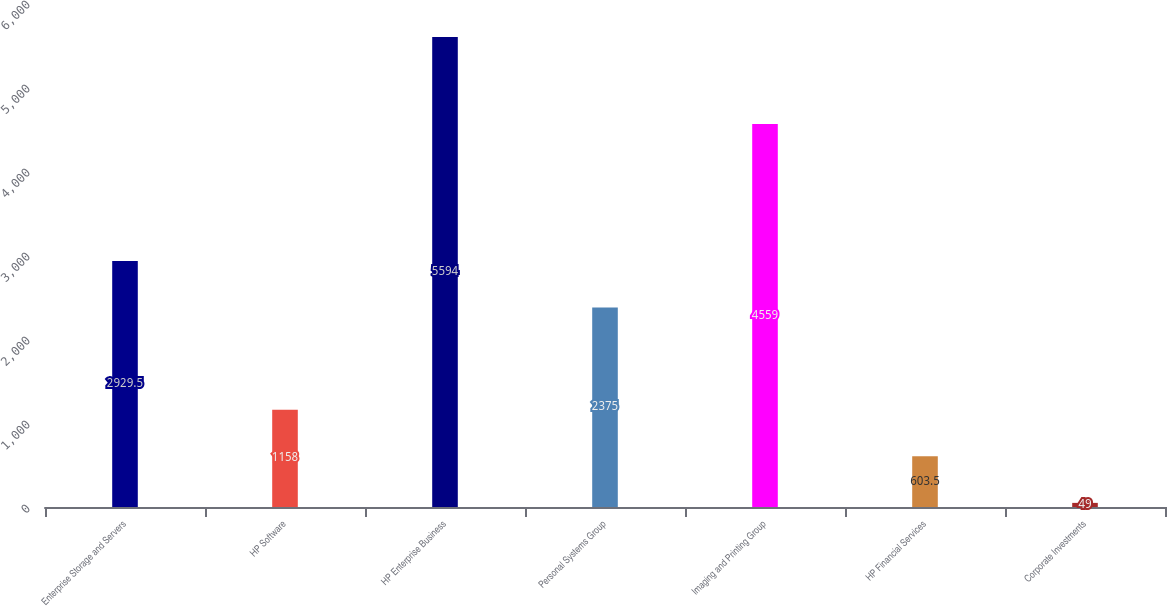Convert chart. <chart><loc_0><loc_0><loc_500><loc_500><bar_chart><fcel>Enterprise Storage and Servers<fcel>HP Software<fcel>HP Enterprise Business<fcel>Personal Systems Group<fcel>Imaging and Printing Group<fcel>HP Financial Services<fcel>Corporate Investments<nl><fcel>2929.5<fcel>1158<fcel>5594<fcel>2375<fcel>4559<fcel>603.5<fcel>49<nl></chart> 